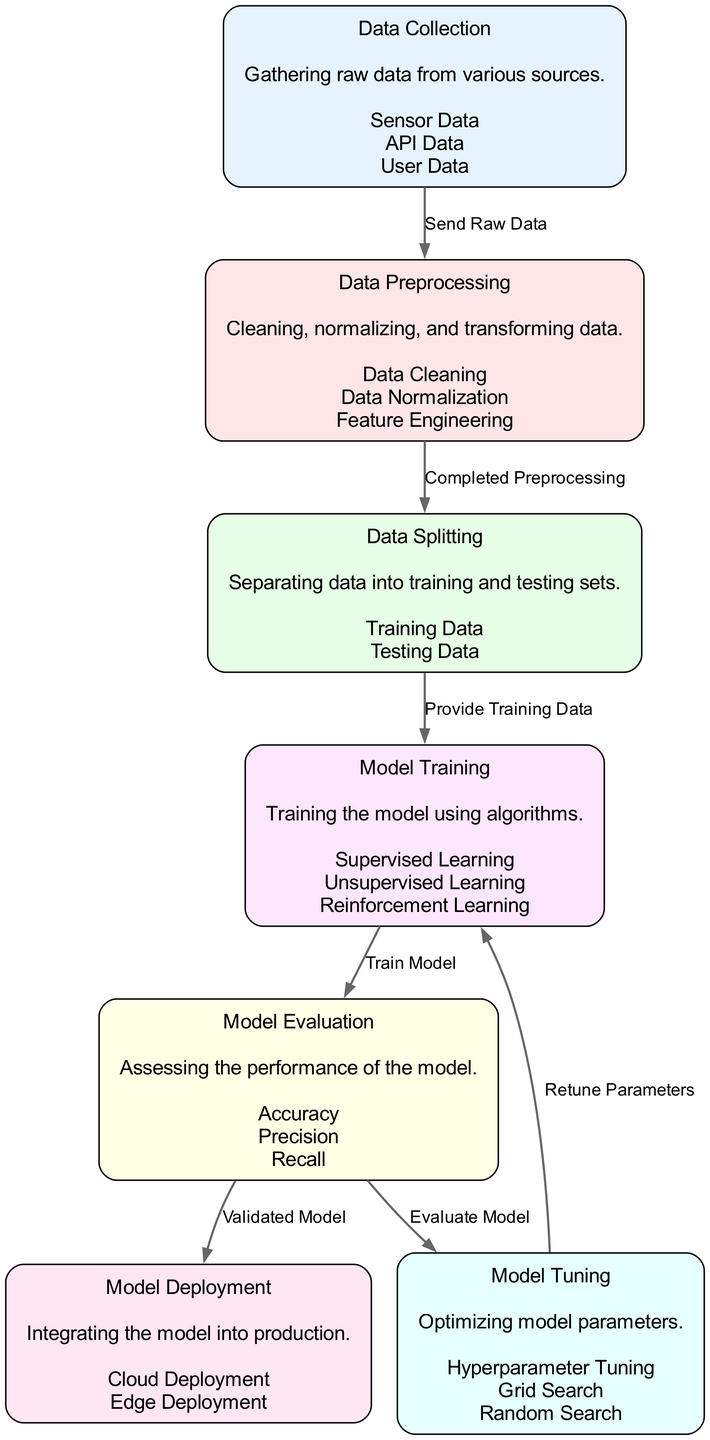What is the first step in the AI model development lifecycle? The diagram indicates that the first step in the AI model development lifecycle is "Data Collection," which involves gathering raw data from various sources.
Answer: Data Collection How many edges are there in the diagram? By counting the lines connecting the nodes, we see there are a total of 6 edges in the diagram that represent the flow from one stage to another.
Answer: 6 What node follows the "Model Evaluation" node? According to the diagram, after "Model Evaluation," the next steps are either "Model Tuning" or "Model Deployment." However, the specific node immediately following is "Model Tuning."
Answer: Model Tuning Which entities are involved in "Data Preprocessing"? The diagram shows that "Data Preprocessing" includes three entities: Data Cleaning, Data Normalization, and Feature Engineering, which are part of the data preparation phase.
Answer: Data Cleaning, Data Normalization, Feature Engineering What is the purpose of "Model Tuning"? The diagram states that the purpose of "Model Tuning" is to optimize model parameters, which is a crucial step for improving model performance once initial training is completed.
Answer: Optimizing model parameters What flow follows the "Model Training" node before "Model Evaluation"? The diagram clearly depicts that after "Model Training," the flow goes directly to "Model Evaluation," indicating that the model's performance will be assessed as the next step.
Answer: Model Evaluation Which step comes after "Data Splitting"? The flowchart shows that after "Data Splitting," the next step is "Model Training," wherein the separated training data is utilized to train the AI model.
Answer: Model Training What validation is required before "Model Deployment"? The diagram specifies that a "Validated Model" is essential before proceeding to "Model Deployment," emphasizing the importance of confirming the model's performance.
Answer: Validated Model 